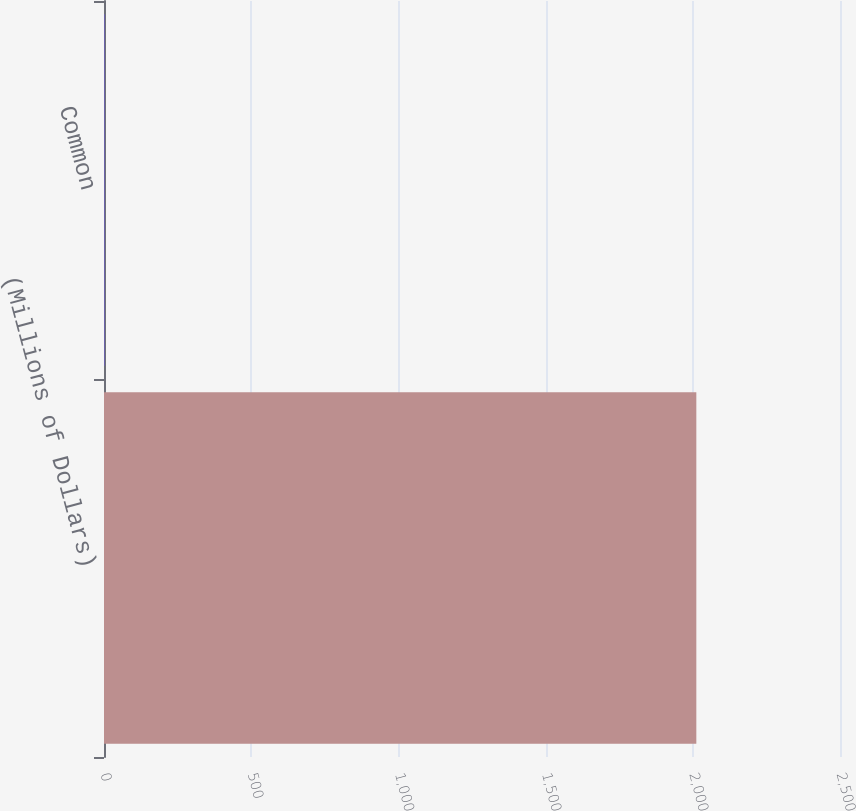<chart> <loc_0><loc_0><loc_500><loc_500><bar_chart><fcel>(Millions of Dollars)<fcel>Common<nl><fcel>2012<fcel>2<nl></chart> 